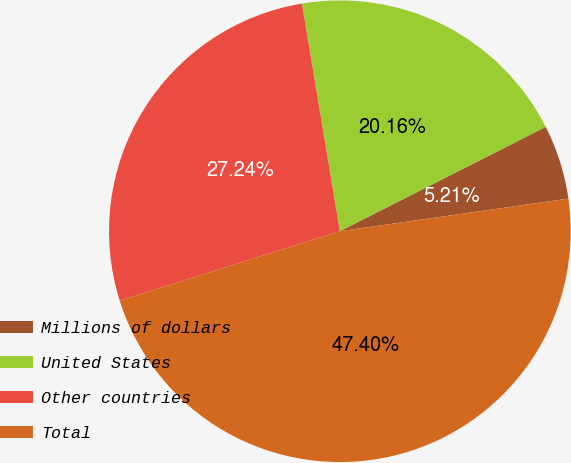Convert chart. <chart><loc_0><loc_0><loc_500><loc_500><pie_chart><fcel>Millions of dollars<fcel>United States<fcel>Other countries<fcel>Total<nl><fcel>5.21%<fcel>20.16%<fcel>27.24%<fcel>47.4%<nl></chart> 